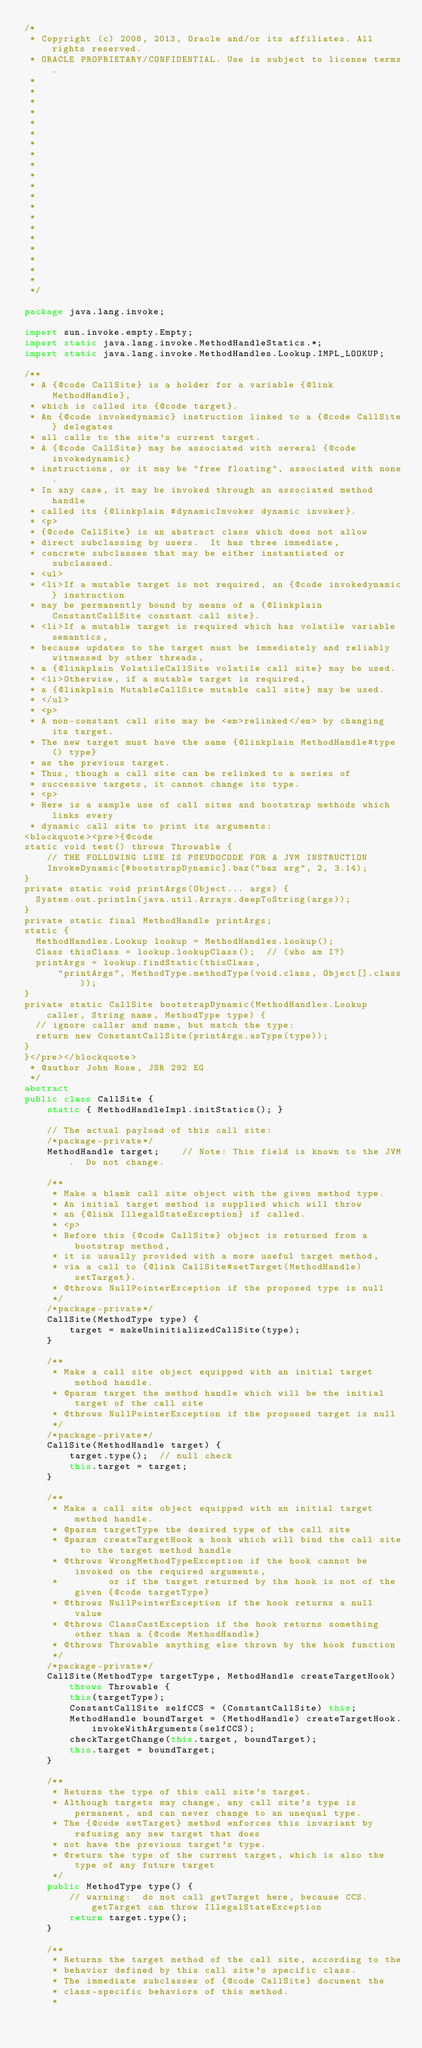Convert code to text. <code><loc_0><loc_0><loc_500><loc_500><_Java_>/*
 * Copyright (c) 2008, 2013, Oracle and/or its affiliates. All rights reserved.
 * ORACLE PROPRIETARY/CONFIDENTIAL. Use is subject to license terms.
 *
 *
 *
 *
 *
 *
 *
 *
 *
 *
 *
 *
 *
 *
 *
 *
 *
 *
 *
 *
 */

package java.lang.invoke;

import sun.invoke.empty.Empty;
import static java.lang.invoke.MethodHandleStatics.*;
import static java.lang.invoke.MethodHandles.Lookup.IMPL_LOOKUP;

/**
 * A {@code CallSite} is a holder for a variable {@link MethodHandle},
 * which is called its {@code target}.
 * An {@code invokedynamic} instruction linked to a {@code CallSite} delegates
 * all calls to the site's current target.
 * A {@code CallSite} may be associated with several {@code invokedynamic}
 * instructions, or it may be "free floating", associated with none.
 * In any case, it may be invoked through an associated method handle
 * called its {@linkplain #dynamicInvoker dynamic invoker}.
 * <p>
 * {@code CallSite} is an abstract class which does not allow
 * direct subclassing by users.  It has three immediate,
 * concrete subclasses that may be either instantiated or subclassed.
 * <ul>
 * <li>If a mutable target is not required, an {@code invokedynamic} instruction
 * may be permanently bound by means of a {@linkplain ConstantCallSite constant call site}.
 * <li>If a mutable target is required which has volatile variable semantics,
 * because updates to the target must be immediately and reliably witnessed by other threads,
 * a {@linkplain VolatileCallSite volatile call site} may be used.
 * <li>Otherwise, if a mutable target is required,
 * a {@linkplain MutableCallSite mutable call site} may be used.
 * </ul>
 * <p>
 * A non-constant call site may be <em>relinked</em> by changing its target.
 * The new target must have the same {@linkplain MethodHandle#type() type}
 * as the previous target.
 * Thus, though a call site can be relinked to a series of
 * successive targets, it cannot change its type.
 * <p>
 * Here is a sample use of call sites and bootstrap methods which links every
 * dynamic call site to print its arguments:
<blockquote><pre>{@code
static void test() throws Throwable {
    // THE FOLLOWING LINE IS PSEUDOCODE FOR A JVM INSTRUCTION
    InvokeDynamic[#bootstrapDynamic].baz("baz arg", 2, 3.14);
}
private static void printArgs(Object... args) {
  System.out.println(java.util.Arrays.deepToString(args));
}
private static final MethodHandle printArgs;
static {
  MethodHandles.Lookup lookup = MethodHandles.lookup();
  Class thisClass = lookup.lookupClass();  // (who am I?)
  printArgs = lookup.findStatic(thisClass,
      "printArgs", MethodType.methodType(void.class, Object[].class));
}
private static CallSite bootstrapDynamic(MethodHandles.Lookup caller, String name, MethodType type) {
  // ignore caller and name, but match the type:
  return new ConstantCallSite(printArgs.asType(type));
}
}</pre></blockquote>
 * @author John Rose, JSR 292 EG
 */
abstract
public class CallSite {
    static { MethodHandleImpl.initStatics(); }

    // The actual payload of this call site:
    /*package-private*/
    MethodHandle target;    // Note: This field is known to the JVM.  Do not change.

    /**
     * Make a blank call site object with the given method type.
     * An initial target method is supplied which will throw
     * an {@link IllegalStateException} if called.
     * <p>
     * Before this {@code CallSite} object is returned from a bootstrap method,
     * it is usually provided with a more useful target method,
     * via a call to {@link CallSite#setTarget(MethodHandle) setTarget}.
     * @throws NullPointerException if the proposed type is null
     */
    /*package-private*/
    CallSite(MethodType type) {
        target = makeUninitializedCallSite(type);
    }

    /**
     * Make a call site object equipped with an initial target method handle.
     * @param target the method handle which will be the initial target of the call site
     * @throws NullPointerException if the proposed target is null
     */
    /*package-private*/
    CallSite(MethodHandle target) {
        target.type();  // null check
        this.target = target;
    }

    /**
     * Make a call site object equipped with an initial target method handle.
     * @param targetType the desired type of the call site
     * @param createTargetHook a hook which will bind the call site to the target method handle
     * @throws WrongMethodTypeException if the hook cannot be invoked on the required arguments,
     *         or if the target returned by the hook is not of the given {@code targetType}
     * @throws NullPointerException if the hook returns a null value
     * @throws ClassCastException if the hook returns something other than a {@code MethodHandle}
     * @throws Throwable anything else thrown by the hook function
     */
    /*package-private*/
    CallSite(MethodType targetType, MethodHandle createTargetHook) throws Throwable {
        this(targetType);
        ConstantCallSite selfCCS = (ConstantCallSite) this;
        MethodHandle boundTarget = (MethodHandle) createTargetHook.invokeWithArguments(selfCCS);
        checkTargetChange(this.target, boundTarget);
        this.target = boundTarget;
    }

    /**
     * Returns the type of this call site's target.
     * Although targets may change, any call site's type is permanent, and can never change to an unequal type.
     * The {@code setTarget} method enforces this invariant by refusing any new target that does
     * not have the previous target's type.
     * @return the type of the current target, which is also the type of any future target
     */
    public MethodType type() {
        // warning:  do not call getTarget here, because CCS.getTarget can throw IllegalStateException
        return target.type();
    }

    /**
     * Returns the target method of the call site, according to the
     * behavior defined by this call site's specific class.
     * The immediate subclasses of {@code CallSite} document the
     * class-specific behaviors of this method.
     *</code> 